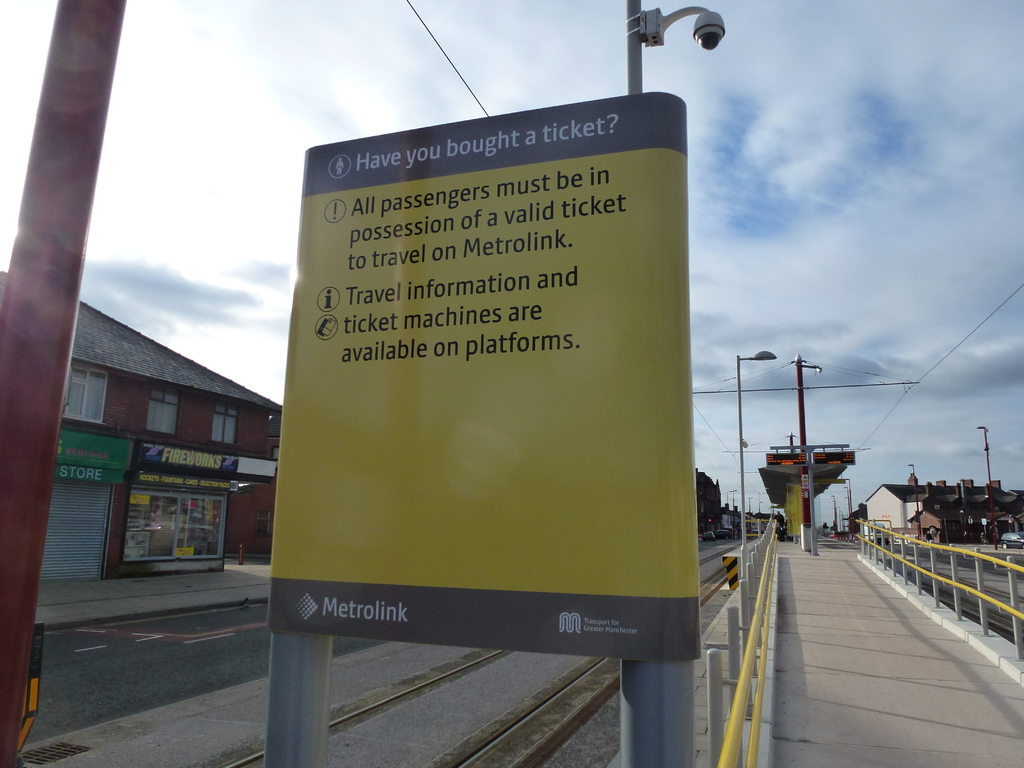Is there anything unique about the way information is presented on the sign? The sign uses a simple yet effective method of communication, utilizing bold and clear text coupled with bullet points to ensure the information is easily digestible. The use of bright yellow for the background not only captures attention but also creates a color association that can aid in quick recognition of transport-related notices. The strategic placement of the Metrolink logo at the bottom reinforces brand identity and authoritative voice. 